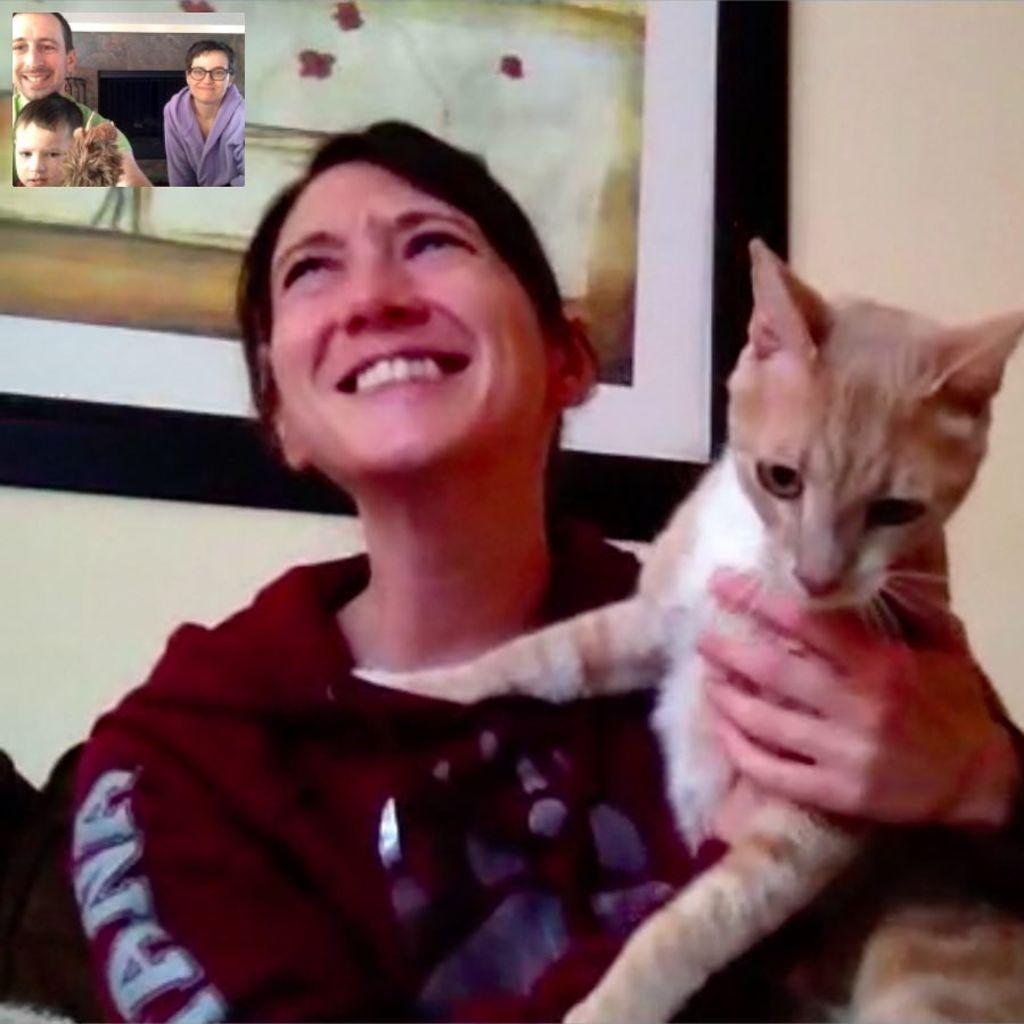Describe this image in one or two sentences. In this image I can see a woman is holding a cat. Here I can see few more people where one person is wearing a specs. 